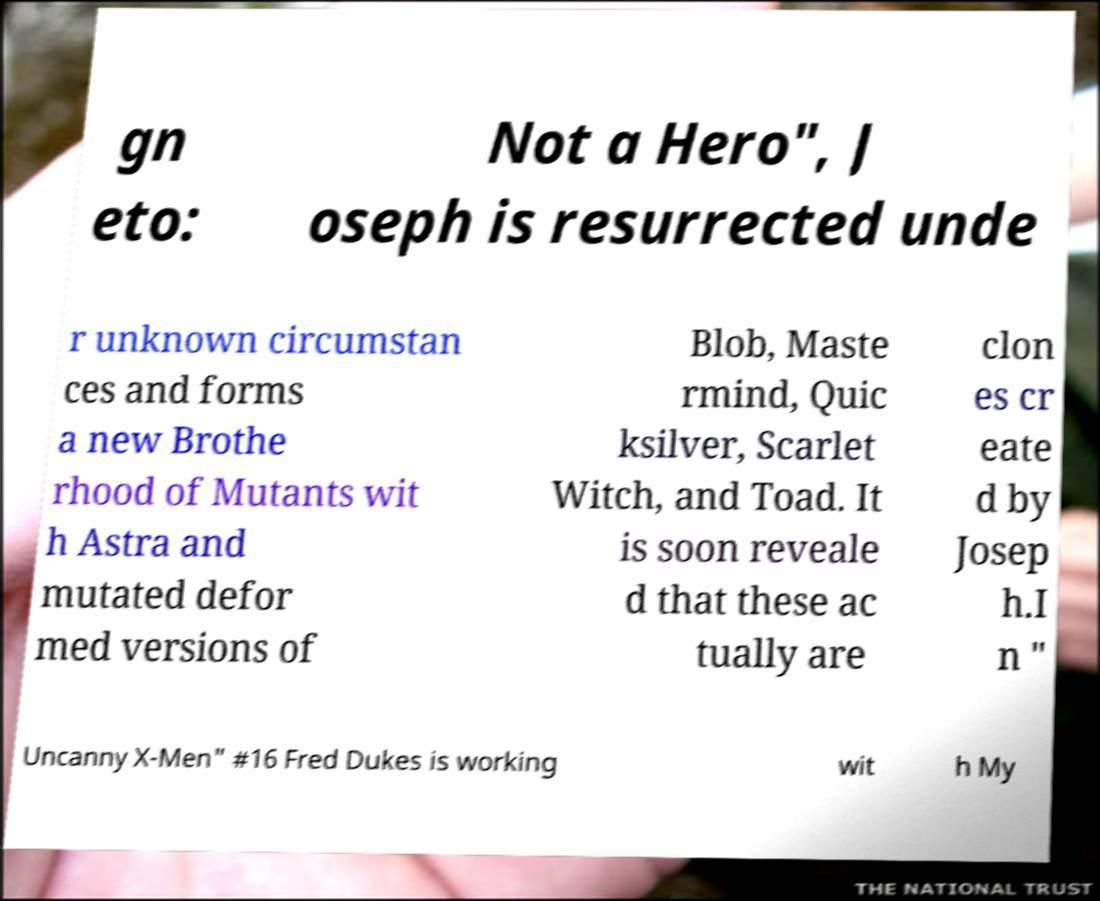There's text embedded in this image that I need extracted. Can you transcribe it verbatim? gn eto: Not a Hero", J oseph is resurrected unde r unknown circumstan ces and forms a new Brothe rhood of Mutants wit h Astra and mutated defor med versions of Blob, Maste rmind, Quic ksilver, Scarlet Witch, and Toad. It is soon reveale d that these ac tually are clon es cr eate d by Josep h.I n " Uncanny X-Men" #16 Fred Dukes is working wit h My 